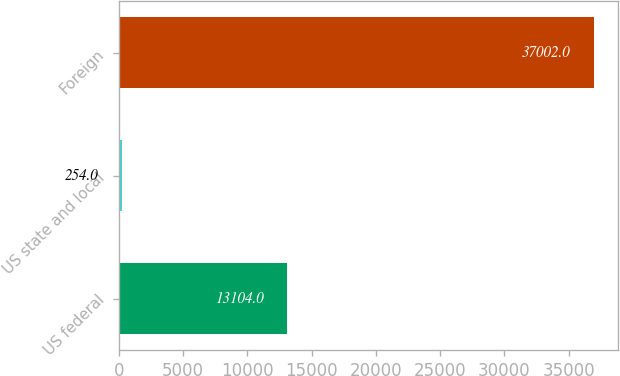Convert chart. <chart><loc_0><loc_0><loc_500><loc_500><bar_chart><fcel>US federal<fcel>US state and local<fcel>Foreign<nl><fcel>13104<fcel>254<fcel>37002<nl></chart> 